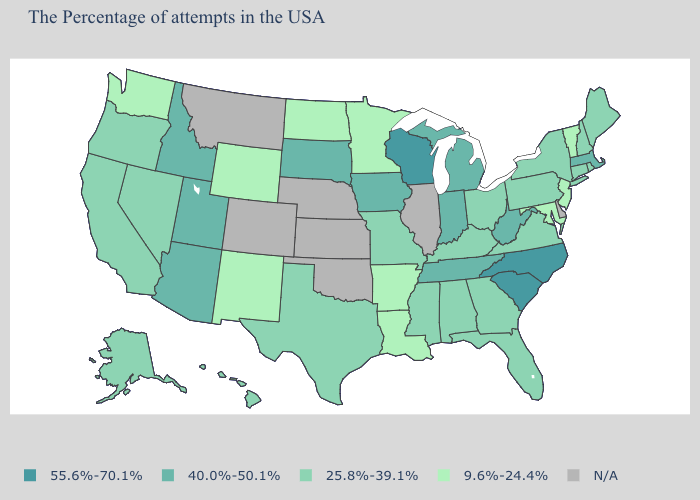Does the first symbol in the legend represent the smallest category?
Short answer required. No. What is the highest value in states that border Tennessee?
Short answer required. 55.6%-70.1%. Name the states that have a value in the range 9.6%-24.4%?
Answer briefly. Vermont, New Jersey, Maryland, Louisiana, Arkansas, Minnesota, North Dakota, Wyoming, New Mexico, Washington. What is the value of Maine?
Write a very short answer. 25.8%-39.1%. Among the states that border Ohio , which have the lowest value?
Be succinct. Pennsylvania, Kentucky. Name the states that have a value in the range 55.6%-70.1%?
Keep it brief. North Carolina, South Carolina, Wisconsin. Which states have the highest value in the USA?
Keep it brief. North Carolina, South Carolina, Wisconsin. What is the value of Montana?
Concise answer only. N/A. Name the states that have a value in the range N/A?
Write a very short answer. Delaware, Illinois, Kansas, Nebraska, Oklahoma, Colorado, Montana. Name the states that have a value in the range 40.0%-50.1%?
Keep it brief. Massachusetts, West Virginia, Michigan, Indiana, Tennessee, Iowa, South Dakota, Utah, Arizona, Idaho. Which states have the highest value in the USA?
Quick response, please. North Carolina, South Carolina, Wisconsin. Does California have the lowest value in the West?
Write a very short answer. No. What is the value of Nevada?
Give a very brief answer. 25.8%-39.1%. Does Wisconsin have the highest value in the MidWest?
Answer briefly. Yes. Does Wyoming have the lowest value in the USA?
Answer briefly. Yes. 